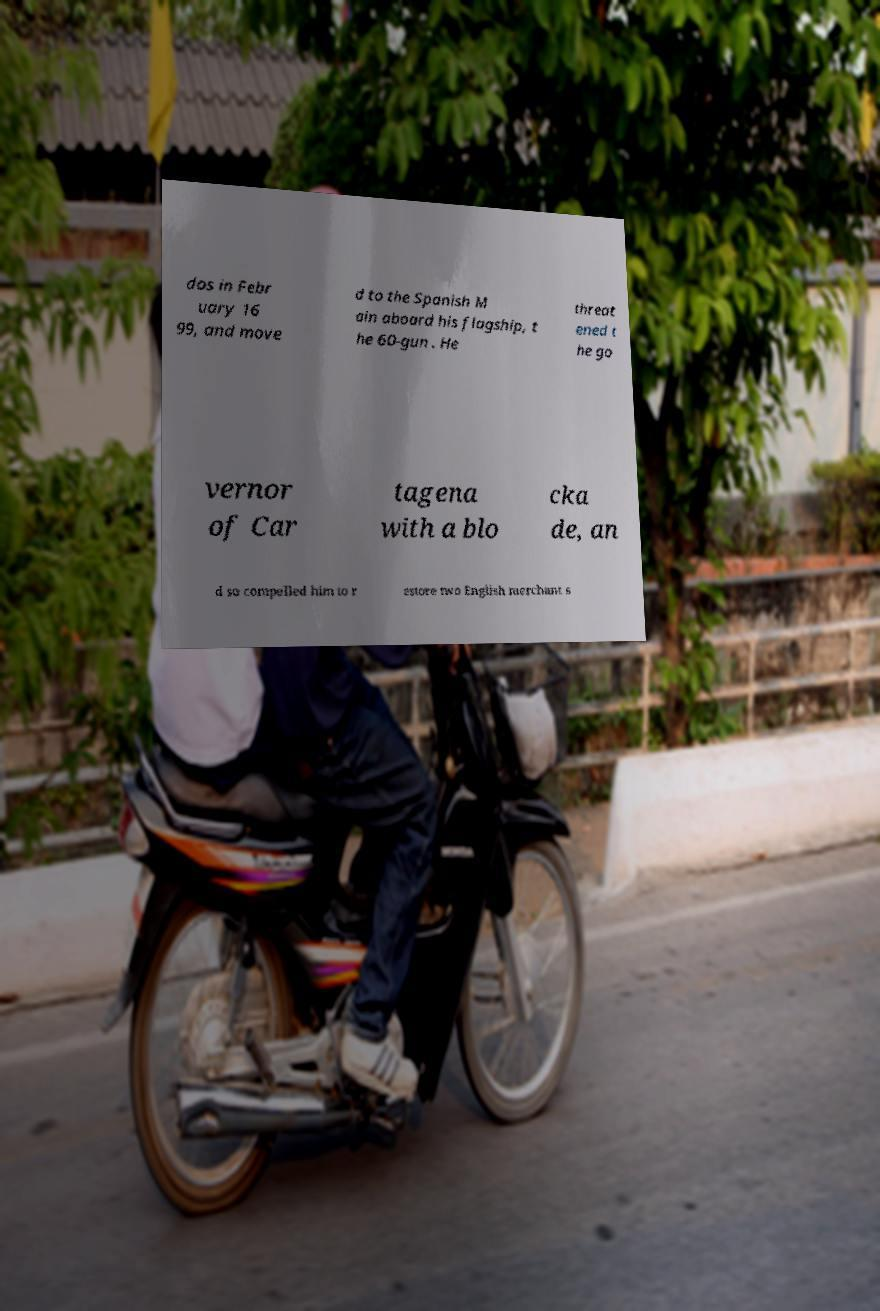Can you accurately transcribe the text from the provided image for me? dos in Febr uary 16 99, and move d to the Spanish M ain aboard his flagship, t he 60-gun . He threat ened t he go vernor of Car tagena with a blo cka de, an d so compelled him to r estore two English merchant s 